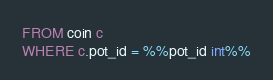Convert code to text. <code><loc_0><loc_0><loc_500><loc_500><_SQL_>FROM coin c
WHERE c.pot_id = %%pot_id int%%
</code> 